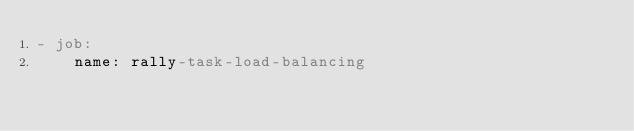<code> <loc_0><loc_0><loc_500><loc_500><_YAML_>- job:
    name: rally-task-load-balancing</code> 